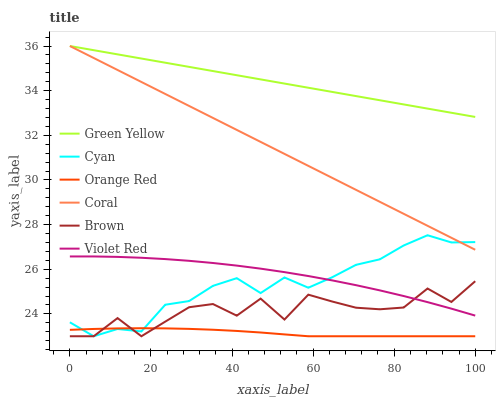Does Orange Red have the minimum area under the curve?
Answer yes or no. Yes. Does Green Yellow have the maximum area under the curve?
Answer yes or no. Yes. Does Violet Red have the minimum area under the curve?
Answer yes or no. No. Does Violet Red have the maximum area under the curve?
Answer yes or no. No. Is Green Yellow the smoothest?
Answer yes or no. Yes. Is Brown the roughest?
Answer yes or no. Yes. Is Violet Red the smoothest?
Answer yes or no. No. Is Violet Red the roughest?
Answer yes or no. No. Does Brown have the lowest value?
Answer yes or no. Yes. Does Violet Red have the lowest value?
Answer yes or no. No. Does Green Yellow have the highest value?
Answer yes or no. Yes. Does Violet Red have the highest value?
Answer yes or no. No. Is Orange Red less than Coral?
Answer yes or no. Yes. Is Green Yellow greater than Violet Red?
Answer yes or no. Yes. Does Cyan intersect Brown?
Answer yes or no. Yes. Is Cyan less than Brown?
Answer yes or no. No. Is Cyan greater than Brown?
Answer yes or no. No. Does Orange Red intersect Coral?
Answer yes or no. No. 